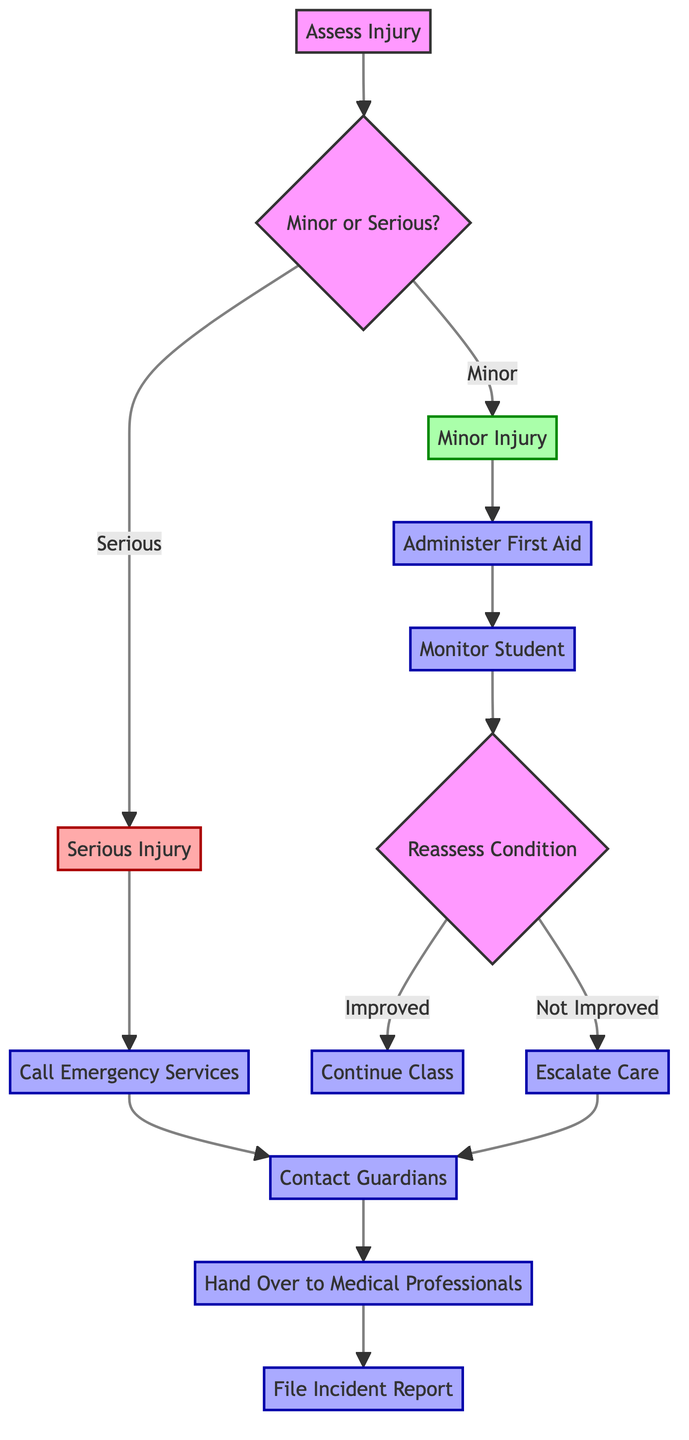What is the first action in the flow chart? The first action is to "Assess Injury," which is indicated as the starting point of the flow chart.
Answer: Assess Injury What are the two types of injuries addressed in this procedure? The two types of injuries noted are "Minor Injury" and "Serious Injury," represented as the two branches following the "Assess Injury" point.
Answer: Minor Injury and Serious Injury What step follows after administering first aid? After "Administer First Aid," the next step is to "Monitor Student," which is directly connected in the flow chart.
Answer: Monitor Student How many main actions are taken for a serious injury? There are two main actions: "Call Emergency Services" and "Contact Guardians," indicating that immediate action and communication are crucial for serious injuries.
Answer: Two What happens if the student's condition does not improve after monitoring? If the student's condition does not improve after monitoring, the flow chart directs to "Escalate Care," indicating the need for further medical attention.
Answer: Escalate Care What is the last step in the procedure for a serious injury? The last step for a serious injury is "File Incident Report," following the action of handing over care to medical professionals.
Answer: File Incident Report What does the flow chart require after contacting guardians? After contacting guardians, the next step is to "Hand Over to Medical Professionals," ensuring the student's injury is managed by trained staff.
Answer: Hand Over to Medical Professionals If the condition is improved, what action should be taken? If the condition has improved, the action to be taken is to "Continue Class," allowing the focus to return to the remainder of the PE session.
Answer: Continue Class What is the response if a minor injury has occurred? For a minor injury, the flow chart leads to administering first aid, which is the immediate response before any further actions are taken.
Answer: Administer First Aid 